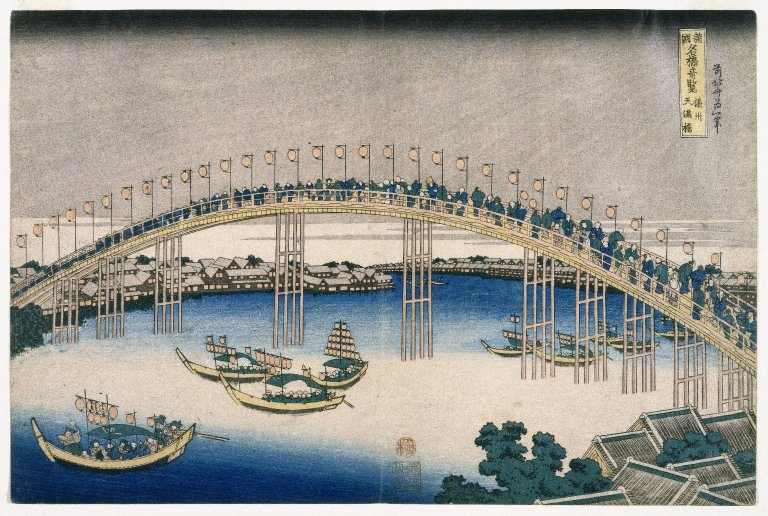What is this photo about? This image is an exquisite example of ukiyo-e, a traditional Japanese woodblock printing technique. It features the famous Ryōgoku Bridge in Edo (modern-day Tokyo), bustling with activity. The bridge arches gracefully over the Sumida River, framed by lanterns that likely indicate a festival or special occasion. Below, boats of various sizes navigate the waters, suggesting a vibrant trade or transport hub. This scene not only captures daily life but also reflects the architectural and cultural dynamism of the Edo period in Japan, offering a snapshot into the historical lifestyle and celebrations of the time. 